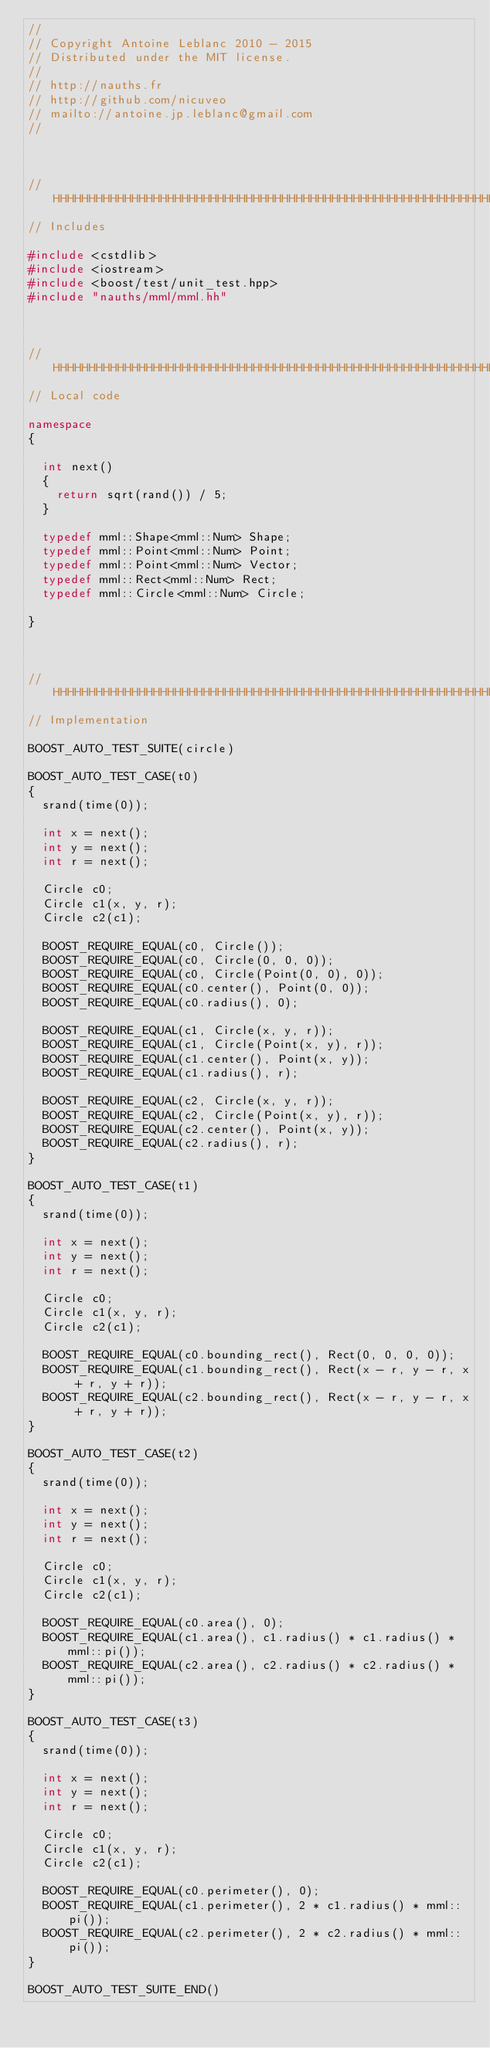<code> <loc_0><loc_0><loc_500><loc_500><_C++_>//
// Copyright Antoine Leblanc 2010 - 2015
// Distributed under the MIT license.
//
// http://nauths.fr
// http://github.com/nicuveo
// mailto://antoine.jp.leblanc@gmail.com
//



//HHHHHHHHHHHHHHHHHHHHHHHHHHHHHHHHHHHHHHHHHHHHHHHHHHHHHHHHHHHHHHHHHHHH
// Includes

#include <cstdlib>
#include <iostream>
#include <boost/test/unit_test.hpp>
#include "nauths/mml/mml.hh"



//HHHHHHHHHHHHHHHHHHHHHHHHHHHHHHHHHHHHHHHHHHHHHHHHHHHHHHHHHHHHHHHHHHHH
// Local code

namespace
{

  int next()
  {
    return sqrt(rand()) / 5;
  }

  typedef mml::Shape<mml::Num> Shape;
  typedef mml::Point<mml::Num> Point;
  typedef mml::Point<mml::Num> Vector;
  typedef mml::Rect<mml::Num> Rect;
  typedef mml::Circle<mml::Num> Circle;

}



//HHHHHHHHHHHHHHHHHHHHHHHHHHHHHHHHHHHHHHHHHHHHHHHHHHHHHHHHHHHHHHHHHHHH
// Implementation

BOOST_AUTO_TEST_SUITE(circle)

BOOST_AUTO_TEST_CASE(t0)
{
  srand(time(0));

  int x = next();
  int y = next();
  int r = next();

  Circle c0;
  Circle c1(x, y, r);
  Circle c2(c1);

  BOOST_REQUIRE_EQUAL(c0, Circle());
  BOOST_REQUIRE_EQUAL(c0, Circle(0, 0, 0));
  BOOST_REQUIRE_EQUAL(c0, Circle(Point(0, 0), 0));
  BOOST_REQUIRE_EQUAL(c0.center(), Point(0, 0));
  BOOST_REQUIRE_EQUAL(c0.radius(), 0);

  BOOST_REQUIRE_EQUAL(c1, Circle(x, y, r));
  BOOST_REQUIRE_EQUAL(c1, Circle(Point(x, y), r));
  BOOST_REQUIRE_EQUAL(c1.center(), Point(x, y));
  BOOST_REQUIRE_EQUAL(c1.radius(), r);

  BOOST_REQUIRE_EQUAL(c2, Circle(x, y, r));
  BOOST_REQUIRE_EQUAL(c2, Circle(Point(x, y), r));
  BOOST_REQUIRE_EQUAL(c2.center(), Point(x, y));
  BOOST_REQUIRE_EQUAL(c2.radius(), r);
}

BOOST_AUTO_TEST_CASE(t1)
{
  srand(time(0));

  int x = next();
  int y = next();
  int r = next();

  Circle c0;
  Circle c1(x, y, r);
  Circle c2(c1);

  BOOST_REQUIRE_EQUAL(c0.bounding_rect(), Rect(0, 0, 0, 0));
  BOOST_REQUIRE_EQUAL(c1.bounding_rect(), Rect(x - r, y - r, x + r, y + r));
  BOOST_REQUIRE_EQUAL(c2.bounding_rect(), Rect(x - r, y - r, x + r, y + r));
}

BOOST_AUTO_TEST_CASE(t2)
{
  srand(time(0));

  int x = next();
  int y = next();
  int r = next();

  Circle c0;
  Circle c1(x, y, r);
  Circle c2(c1);

  BOOST_REQUIRE_EQUAL(c0.area(), 0);
  BOOST_REQUIRE_EQUAL(c1.area(), c1.radius() * c1.radius() * mml::pi());
  BOOST_REQUIRE_EQUAL(c2.area(), c2.radius() * c2.radius() * mml::pi());
}

BOOST_AUTO_TEST_CASE(t3)
{
  srand(time(0));

  int x = next();
  int y = next();
  int r = next();

  Circle c0;
  Circle c1(x, y, r);
  Circle c2(c1);

  BOOST_REQUIRE_EQUAL(c0.perimeter(), 0);
  BOOST_REQUIRE_EQUAL(c1.perimeter(), 2 * c1.radius() * mml::pi());
  BOOST_REQUIRE_EQUAL(c2.perimeter(), 2 * c2.radius() * mml::pi());
}

BOOST_AUTO_TEST_SUITE_END()
</code> 